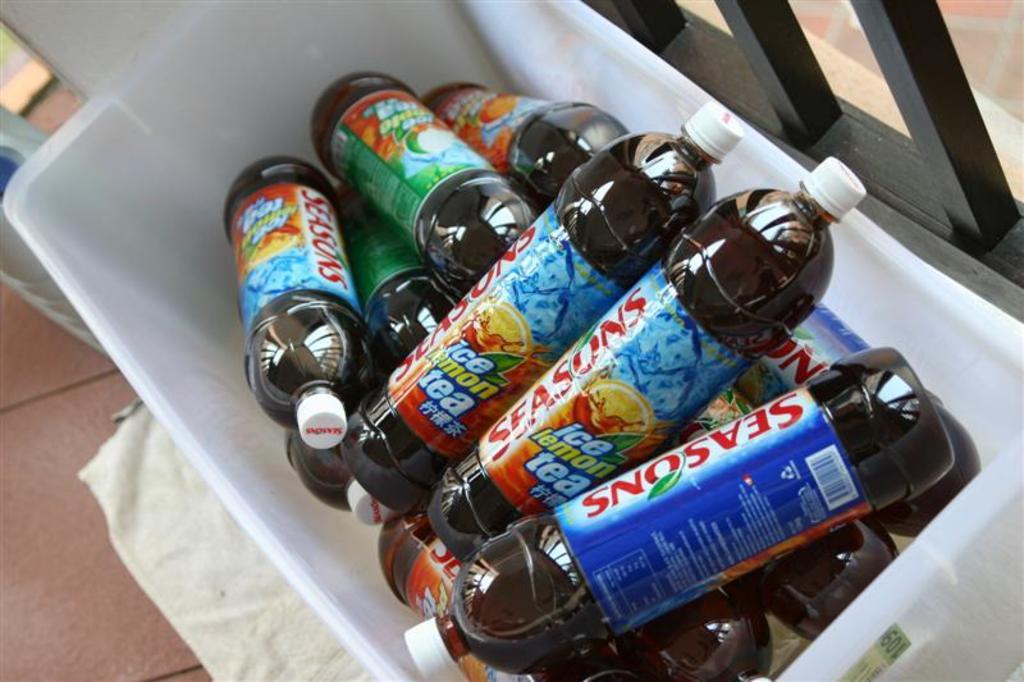What flavor tea is this?
Your answer should be very brief. Lemon. 